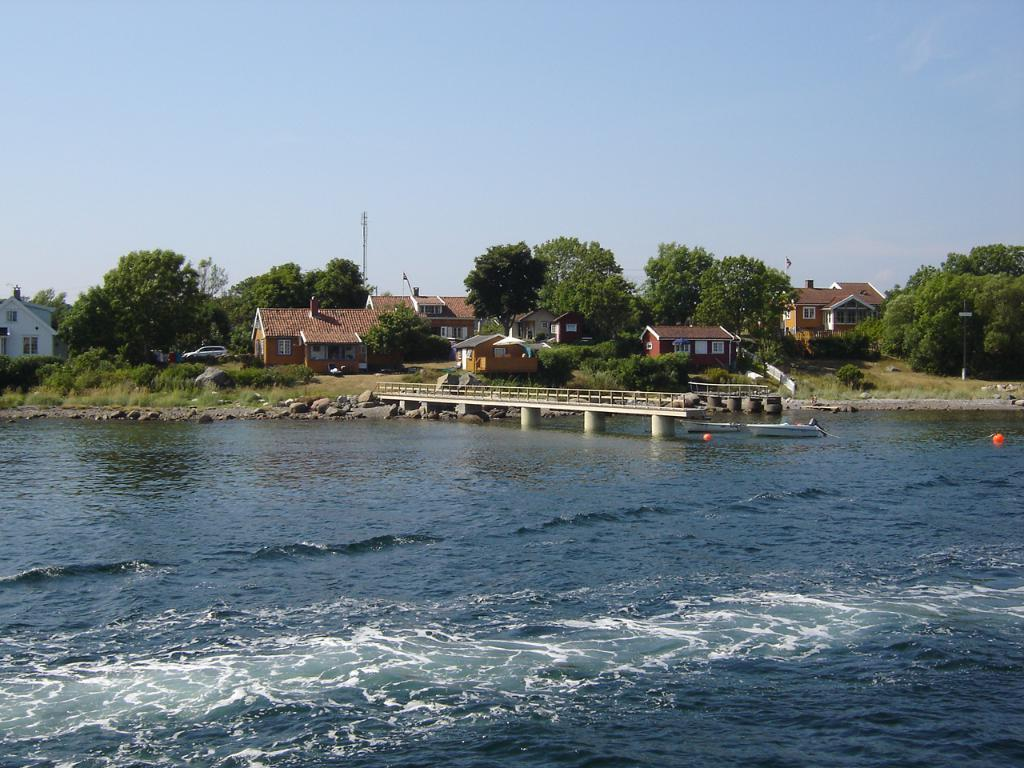What type of natural feature can be seen in the image? There is a river in the image. What type of structures are present in the image? There are houses in the image. What type of vegetation is present in the image? There are trees in the image. What is visible in the background of the image? The sky is visible in the background of the image. How does the weather affect the quiet development in the image? There is no mention of weather or development in the image. The image only features a river, houses, trees, and the sky. 